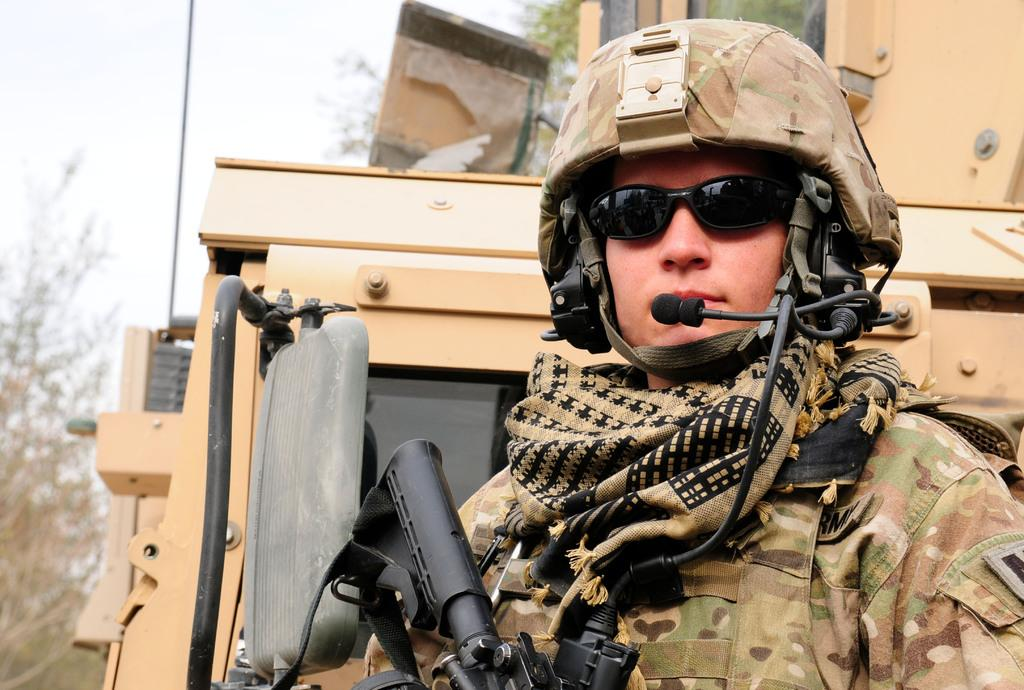What is the main subject of the image? There is a person standing in the image. What is the person holding in the image? The person is holding a gun. What can be seen in the background of the image? There is an object that looks like a truck and trees in the background. What is visible in the sky in the image? The sky is visible in the background of the image. What type of cushion is being used to surf the wave in the image? There is no cushion or wave present in the image; it features a person holding a gun and a background with a truck, trees, and sky. 